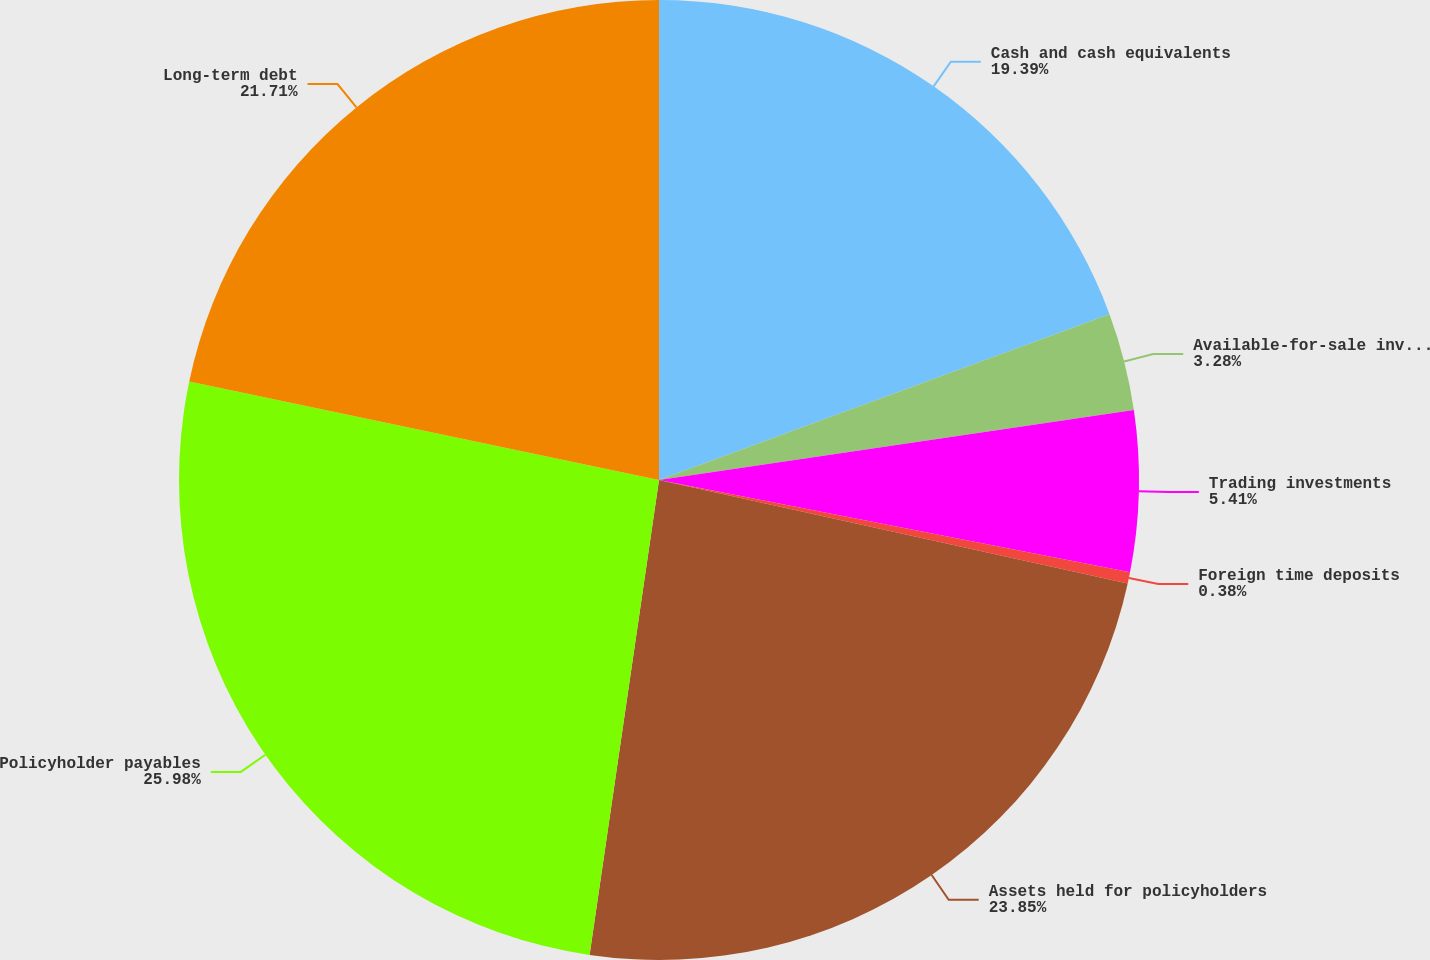<chart> <loc_0><loc_0><loc_500><loc_500><pie_chart><fcel>Cash and cash equivalents<fcel>Available-for-sale investments<fcel>Trading investments<fcel>Foreign time deposits<fcel>Assets held for policyholders<fcel>Policyholder payables<fcel>Long-term debt<nl><fcel>19.39%<fcel>3.28%<fcel>5.41%<fcel>0.38%<fcel>23.85%<fcel>25.98%<fcel>21.71%<nl></chart> 